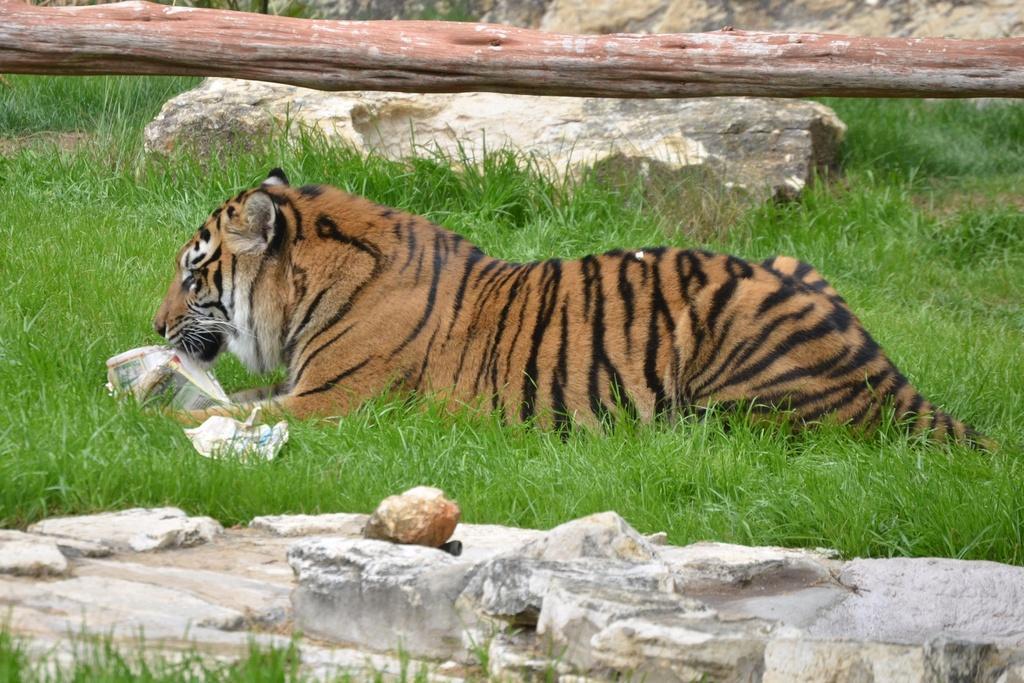Please provide a concise description of this image. In this picture, we can see a tiger with some object, we can see the ground with grass, stones, and trunk of tree. 